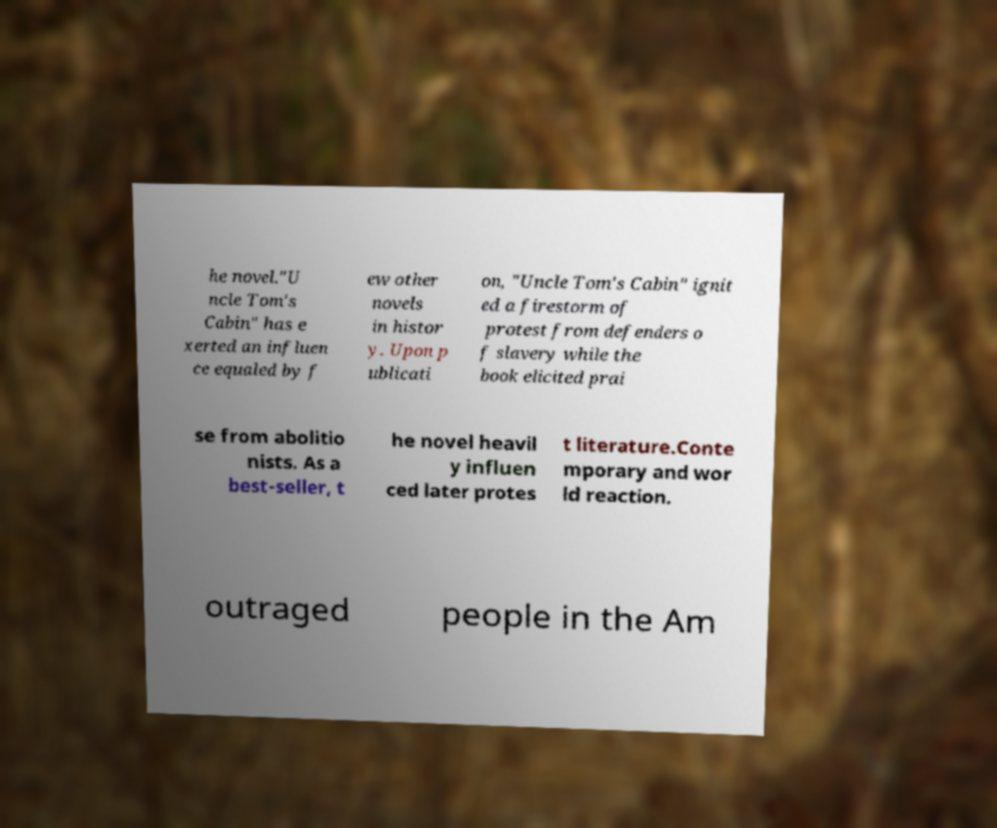Could you assist in decoding the text presented in this image and type it out clearly? he novel."U ncle Tom's Cabin" has e xerted an influen ce equaled by f ew other novels in histor y. Upon p ublicati on, "Uncle Tom's Cabin" ignit ed a firestorm of protest from defenders o f slavery while the book elicited prai se from abolitio nists. As a best-seller, t he novel heavil y influen ced later protes t literature.Conte mporary and wor ld reaction. outraged people in the Am 